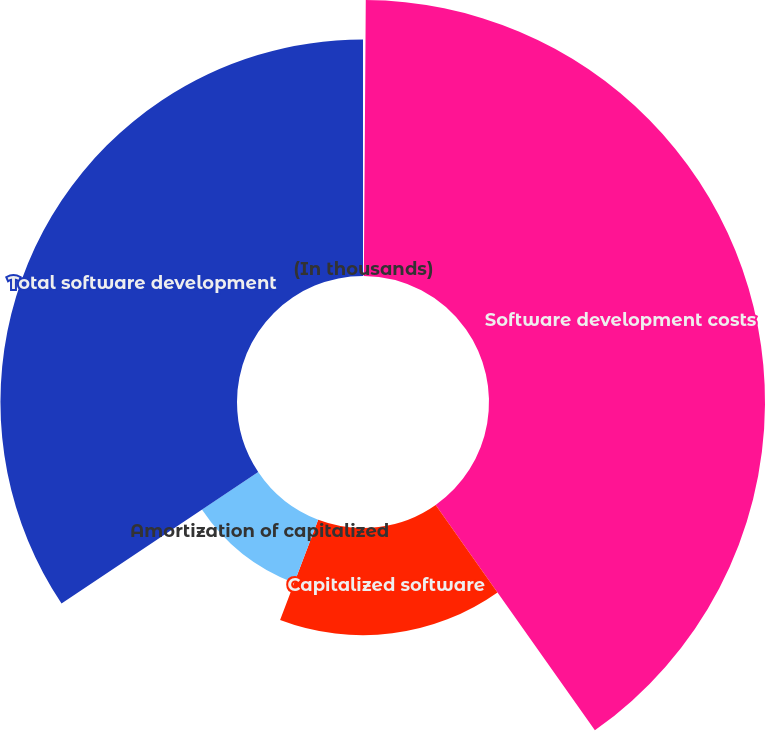<chart> <loc_0><loc_0><loc_500><loc_500><pie_chart><fcel>(In thousands)<fcel>Software development costs<fcel>Capitalized software<fcel>Amortization of capitalized<fcel>Total software development<nl><fcel>0.11%<fcel>40.1%<fcel>15.57%<fcel>9.84%<fcel>34.37%<nl></chart> 